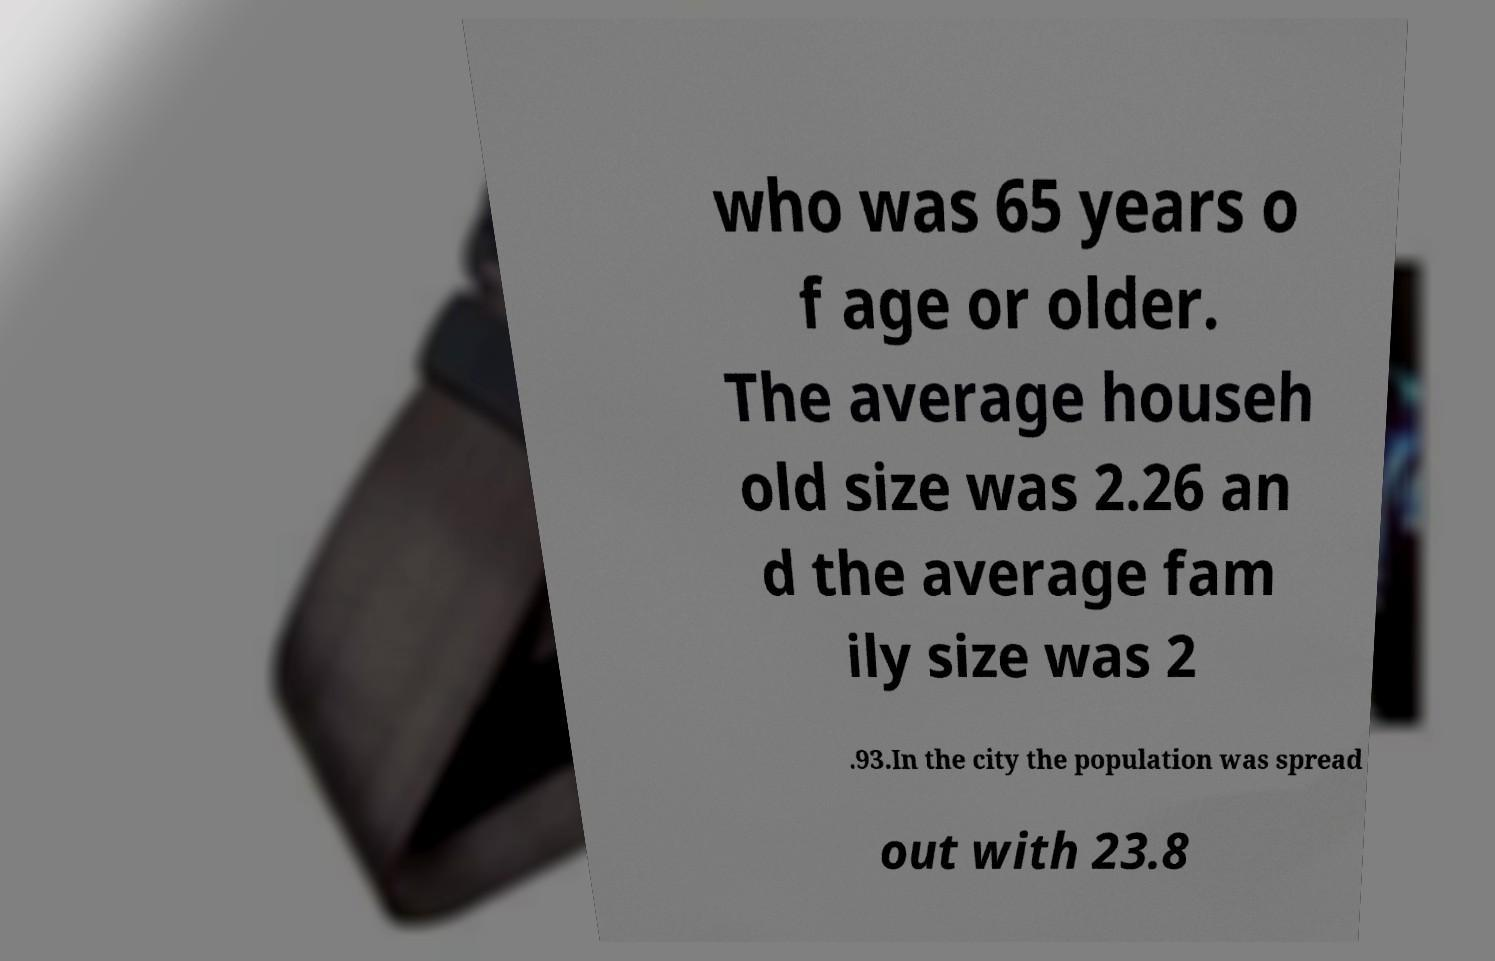Please identify and transcribe the text found in this image. who was 65 years o f age or older. The average househ old size was 2.26 an d the average fam ily size was 2 .93.In the city the population was spread out with 23.8 